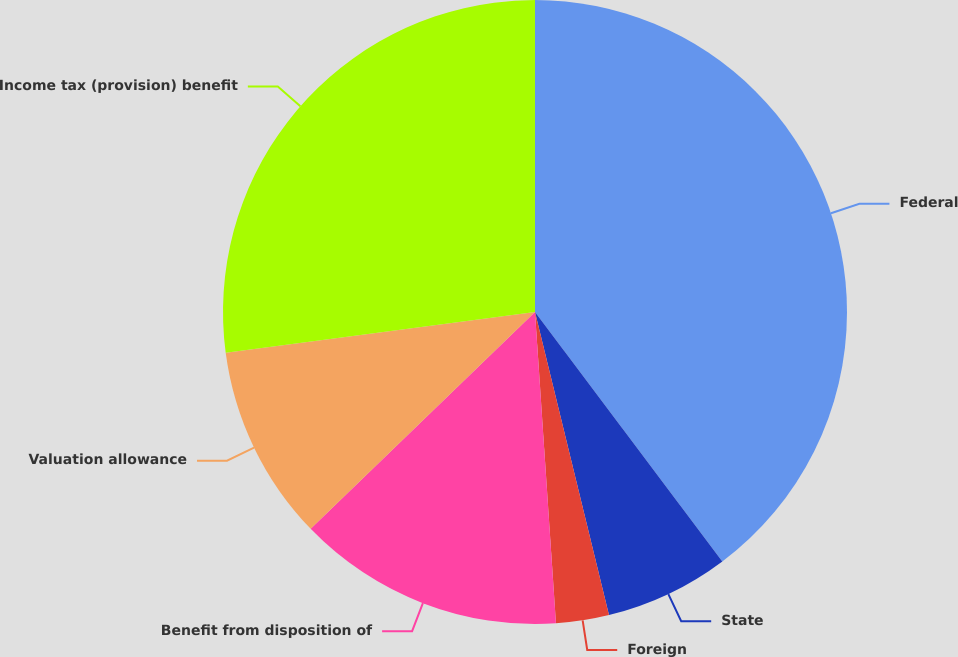Convert chart. <chart><loc_0><loc_0><loc_500><loc_500><pie_chart><fcel>Federal<fcel>State<fcel>Foreign<fcel>Benefit from disposition of<fcel>Valuation allowance<fcel>Income tax (provision) benefit<nl><fcel>39.75%<fcel>6.44%<fcel>2.74%<fcel>13.84%<fcel>10.14%<fcel>27.09%<nl></chart> 